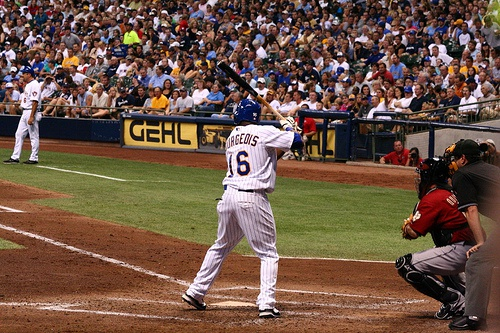Describe the objects in this image and their specific colors. I can see people in purple, black, maroon, brown, and gray tones, people in purple, lavender, darkgray, gray, and black tones, people in purple, black, maroon, gray, and brown tones, people in purple, black, maroon, and gray tones, and people in purple, lavender, darkgray, gray, and black tones in this image. 